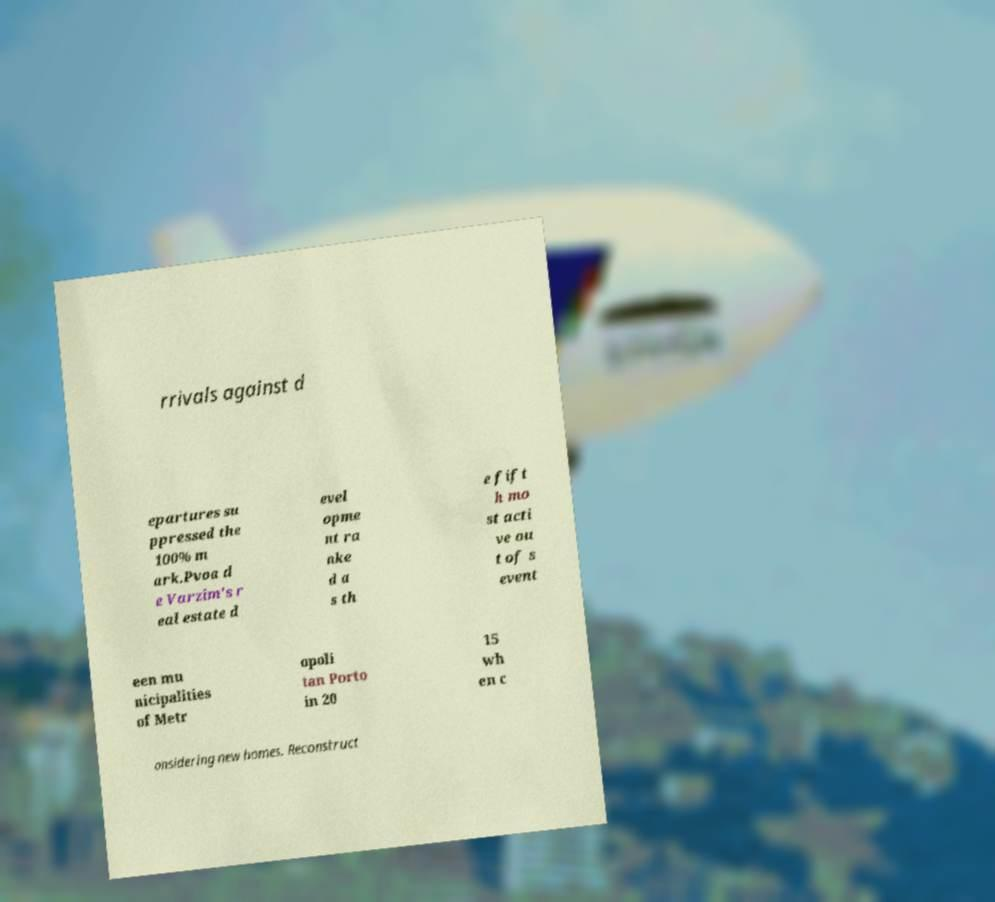Can you read and provide the text displayed in the image?This photo seems to have some interesting text. Can you extract and type it out for me? rrivals against d epartures su ppressed the 100% m ark.Pvoa d e Varzim's r eal estate d evel opme nt ra nke d a s th e fift h mo st acti ve ou t of s event een mu nicipalities of Metr opoli tan Porto in 20 15 wh en c onsidering new homes. Reconstruct 